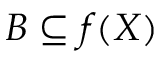<formula> <loc_0><loc_0><loc_500><loc_500>B \subseteq f ( X )</formula> 